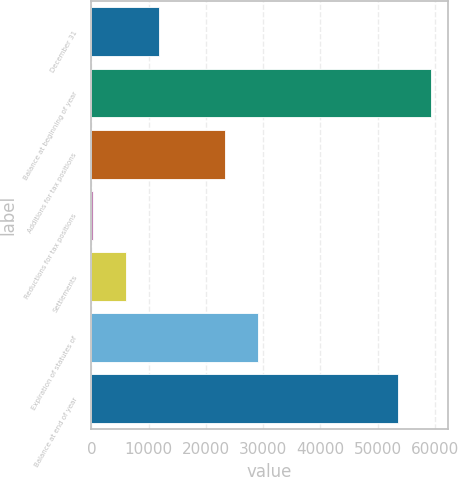<chart> <loc_0><loc_0><loc_500><loc_500><bar_chart><fcel>December 31<fcel>Balance at beginning of year<fcel>Additions for tax positions<fcel>Reductions for tax positions<fcel>Settlements<fcel>Expiration of statutes of<fcel>Balance at end of year<nl><fcel>11768.8<fcel>59332.4<fcel>23327.6<fcel>210<fcel>5989.4<fcel>29107<fcel>53553<nl></chart> 